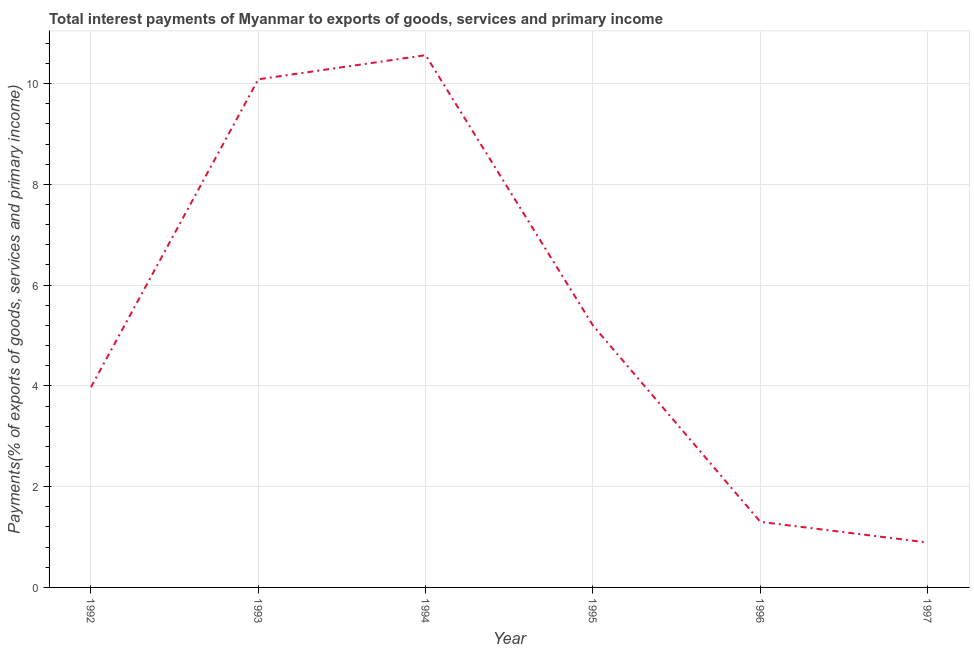What is the total interest payments on external debt in 1996?
Provide a succinct answer. 1.3. Across all years, what is the maximum total interest payments on external debt?
Your response must be concise. 10.56. Across all years, what is the minimum total interest payments on external debt?
Your answer should be compact. 0.89. In which year was the total interest payments on external debt maximum?
Offer a terse response. 1994. In which year was the total interest payments on external debt minimum?
Offer a very short reply. 1997. What is the sum of the total interest payments on external debt?
Make the answer very short. 32.01. What is the difference between the total interest payments on external debt in 1993 and 1996?
Provide a short and direct response. 8.78. What is the average total interest payments on external debt per year?
Ensure brevity in your answer.  5.34. What is the median total interest payments on external debt?
Offer a terse response. 4.59. Do a majority of the years between 1996 and 1993 (inclusive) have total interest payments on external debt greater than 4.8 %?
Offer a very short reply. Yes. What is the ratio of the total interest payments on external debt in 1994 to that in 1995?
Provide a short and direct response. 2.03. Is the total interest payments on external debt in 1992 less than that in 1994?
Offer a very short reply. Yes. What is the difference between the highest and the second highest total interest payments on external debt?
Offer a terse response. 0.48. What is the difference between the highest and the lowest total interest payments on external debt?
Offer a very short reply. 9.67. In how many years, is the total interest payments on external debt greater than the average total interest payments on external debt taken over all years?
Your response must be concise. 2. Does the total interest payments on external debt monotonically increase over the years?
Offer a very short reply. No. How many lines are there?
Provide a succinct answer. 1. How many years are there in the graph?
Your answer should be compact. 6. What is the title of the graph?
Provide a short and direct response. Total interest payments of Myanmar to exports of goods, services and primary income. What is the label or title of the Y-axis?
Provide a short and direct response. Payments(% of exports of goods, services and primary income). What is the Payments(% of exports of goods, services and primary income) in 1992?
Offer a very short reply. 3.97. What is the Payments(% of exports of goods, services and primary income) in 1993?
Ensure brevity in your answer.  10.08. What is the Payments(% of exports of goods, services and primary income) of 1994?
Offer a terse response. 10.56. What is the Payments(% of exports of goods, services and primary income) in 1995?
Give a very brief answer. 5.2. What is the Payments(% of exports of goods, services and primary income) of 1996?
Keep it short and to the point. 1.3. What is the Payments(% of exports of goods, services and primary income) of 1997?
Ensure brevity in your answer.  0.89. What is the difference between the Payments(% of exports of goods, services and primary income) in 1992 and 1993?
Provide a succinct answer. -6.11. What is the difference between the Payments(% of exports of goods, services and primary income) in 1992 and 1994?
Offer a terse response. -6.59. What is the difference between the Payments(% of exports of goods, services and primary income) in 1992 and 1995?
Ensure brevity in your answer.  -1.22. What is the difference between the Payments(% of exports of goods, services and primary income) in 1992 and 1996?
Make the answer very short. 2.67. What is the difference between the Payments(% of exports of goods, services and primary income) in 1992 and 1997?
Your answer should be very brief. 3.08. What is the difference between the Payments(% of exports of goods, services and primary income) in 1993 and 1994?
Give a very brief answer. -0.48. What is the difference between the Payments(% of exports of goods, services and primary income) in 1993 and 1995?
Keep it short and to the point. 4.89. What is the difference between the Payments(% of exports of goods, services and primary income) in 1993 and 1996?
Offer a terse response. 8.78. What is the difference between the Payments(% of exports of goods, services and primary income) in 1993 and 1997?
Give a very brief answer. 9.19. What is the difference between the Payments(% of exports of goods, services and primary income) in 1994 and 1995?
Keep it short and to the point. 5.37. What is the difference between the Payments(% of exports of goods, services and primary income) in 1994 and 1996?
Offer a very short reply. 9.26. What is the difference between the Payments(% of exports of goods, services and primary income) in 1994 and 1997?
Your response must be concise. 9.67. What is the difference between the Payments(% of exports of goods, services and primary income) in 1995 and 1996?
Provide a short and direct response. 3.9. What is the difference between the Payments(% of exports of goods, services and primary income) in 1995 and 1997?
Offer a terse response. 4.31. What is the difference between the Payments(% of exports of goods, services and primary income) in 1996 and 1997?
Offer a very short reply. 0.41. What is the ratio of the Payments(% of exports of goods, services and primary income) in 1992 to that in 1993?
Your answer should be very brief. 0.39. What is the ratio of the Payments(% of exports of goods, services and primary income) in 1992 to that in 1994?
Provide a succinct answer. 0.38. What is the ratio of the Payments(% of exports of goods, services and primary income) in 1992 to that in 1995?
Make the answer very short. 0.76. What is the ratio of the Payments(% of exports of goods, services and primary income) in 1992 to that in 1996?
Provide a short and direct response. 3.05. What is the ratio of the Payments(% of exports of goods, services and primary income) in 1992 to that in 1997?
Your response must be concise. 4.46. What is the ratio of the Payments(% of exports of goods, services and primary income) in 1993 to that in 1994?
Your response must be concise. 0.95. What is the ratio of the Payments(% of exports of goods, services and primary income) in 1993 to that in 1995?
Offer a terse response. 1.94. What is the ratio of the Payments(% of exports of goods, services and primary income) in 1993 to that in 1996?
Offer a very short reply. 7.75. What is the ratio of the Payments(% of exports of goods, services and primary income) in 1993 to that in 1997?
Offer a very short reply. 11.32. What is the ratio of the Payments(% of exports of goods, services and primary income) in 1994 to that in 1995?
Give a very brief answer. 2.03. What is the ratio of the Payments(% of exports of goods, services and primary income) in 1994 to that in 1996?
Ensure brevity in your answer.  8.12. What is the ratio of the Payments(% of exports of goods, services and primary income) in 1994 to that in 1997?
Your response must be concise. 11.86. What is the ratio of the Payments(% of exports of goods, services and primary income) in 1995 to that in 1996?
Provide a succinct answer. 3.99. What is the ratio of the Payments(% of exports of goods, services and primary income) in 1995 to that in 1997?
Keep it short and to the point. 5.83. What is the ratio of the Payments(% of exports of goods, services and primary income) in 1996 to that in 1997?
Make the answer very short. 1.46. 